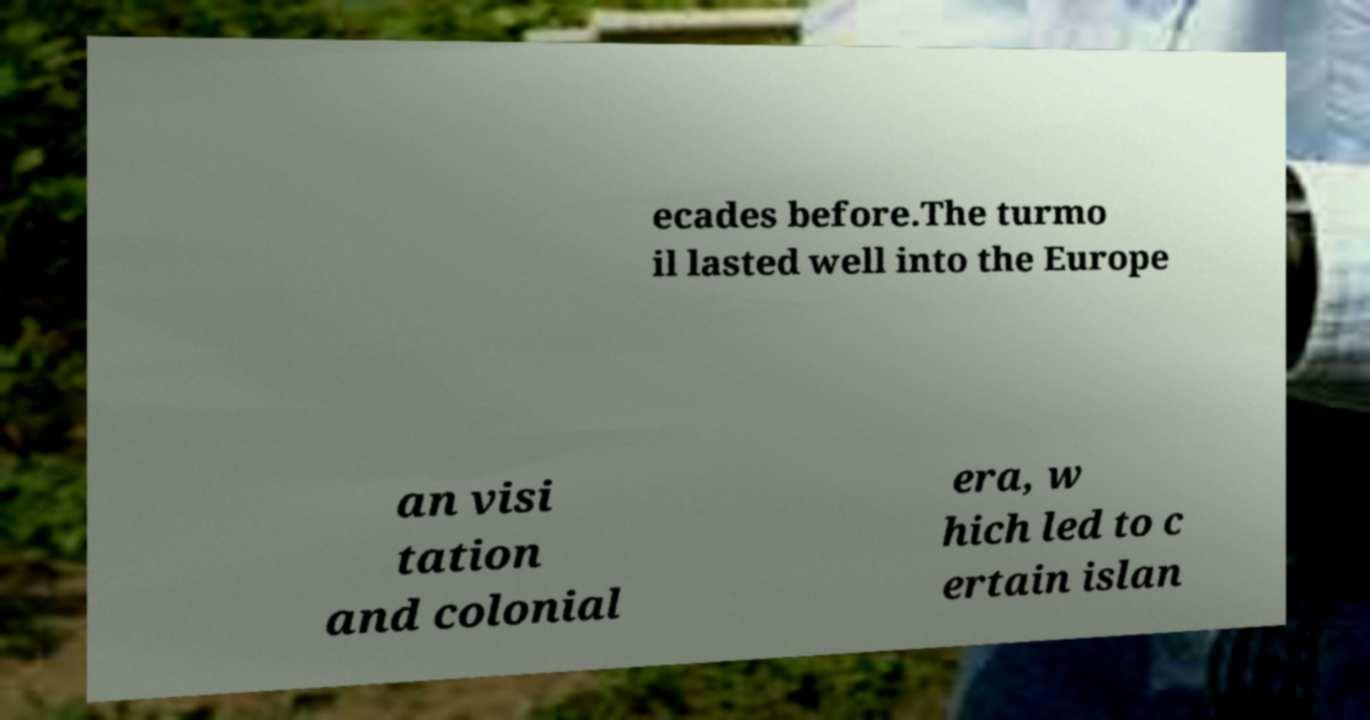Can you read and provide the text displayed in the image?This photo seems to have some interesting text. Can you extract and type it out for me? ecades before.The turmo il lasted well into the Europe an visi tation and colonial era, w hich led to c ertain islan 